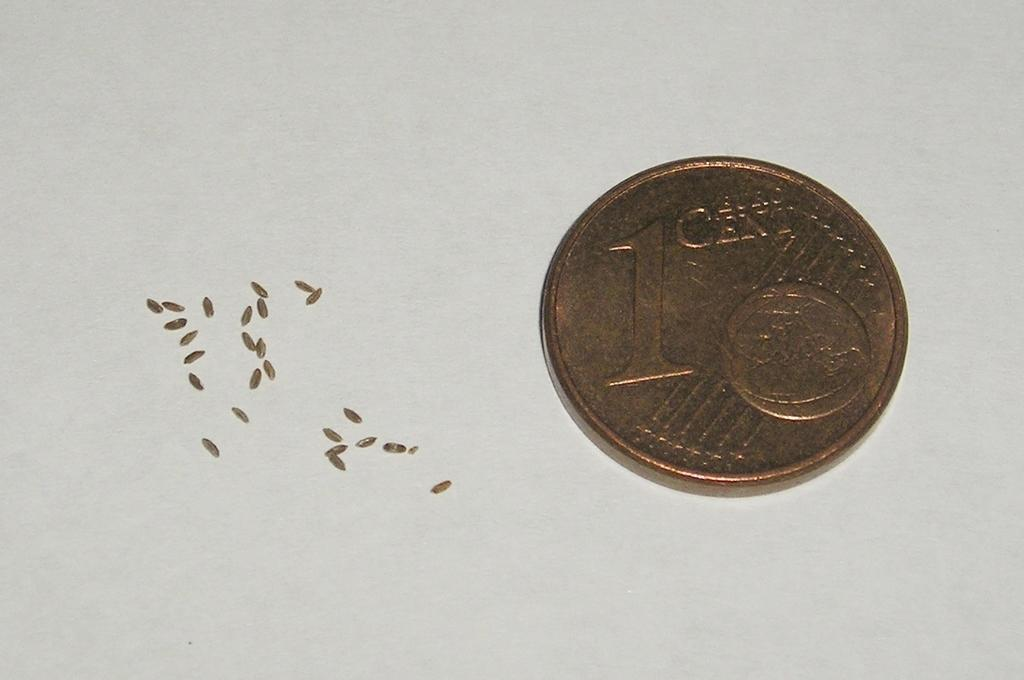Provide a one-sentence caption for the provided image. A one cent coin sits to the right of some metallic colored metal shavings. 